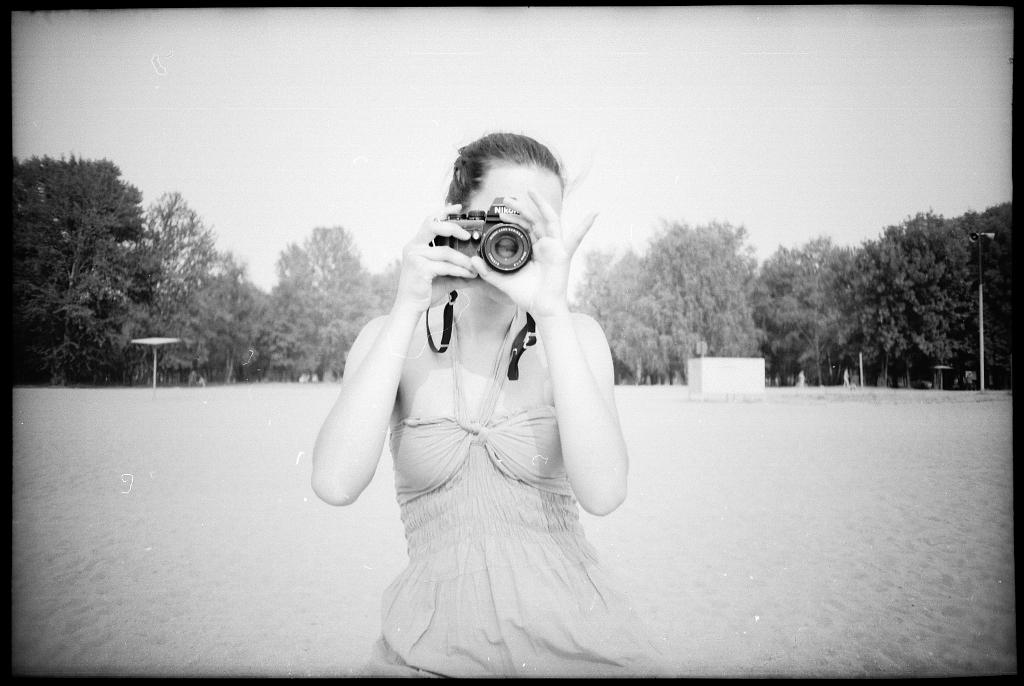Who is the main subject in the image? There is a woman in the image. What is the woman doing in the image? The woman is holding a camera and taking a picture. What can be seen in the background of the image? There are trees, a pole, a box, and the sky visible in the background of the image. Where is the library located in the image? There is no library present in the image. What type of order is the woman following while taking the picture? The image does not provide information about any specific order the woman is following while taking the picture. 